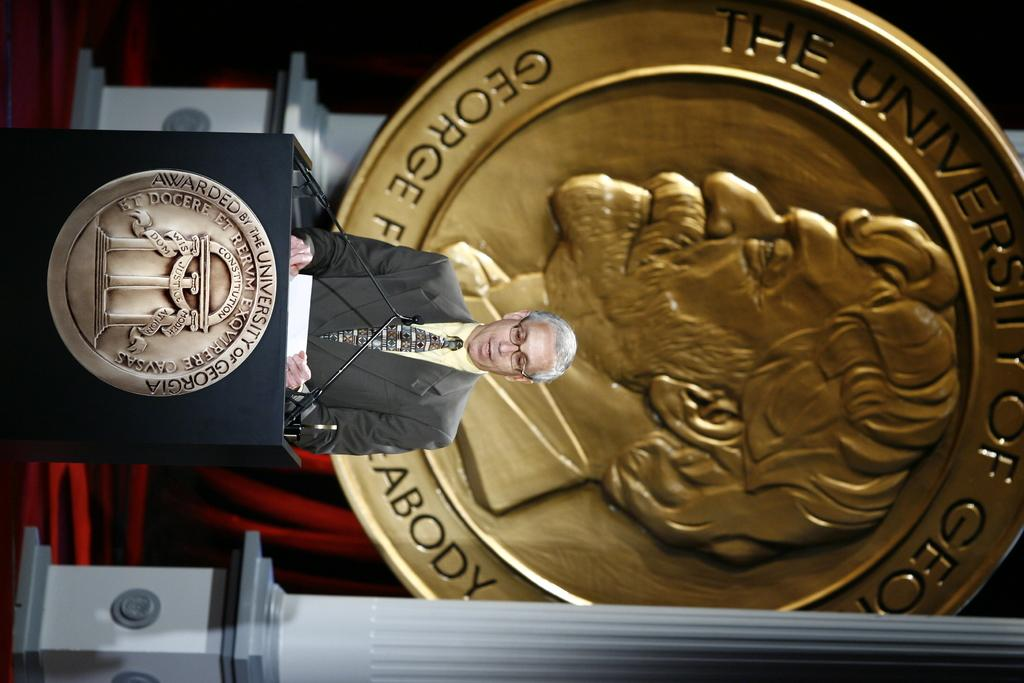<image>
Offer a succinct explanation of the picture presented. A man speaking at a podium has a large gold medallion behind him that says the University of Georgia. 